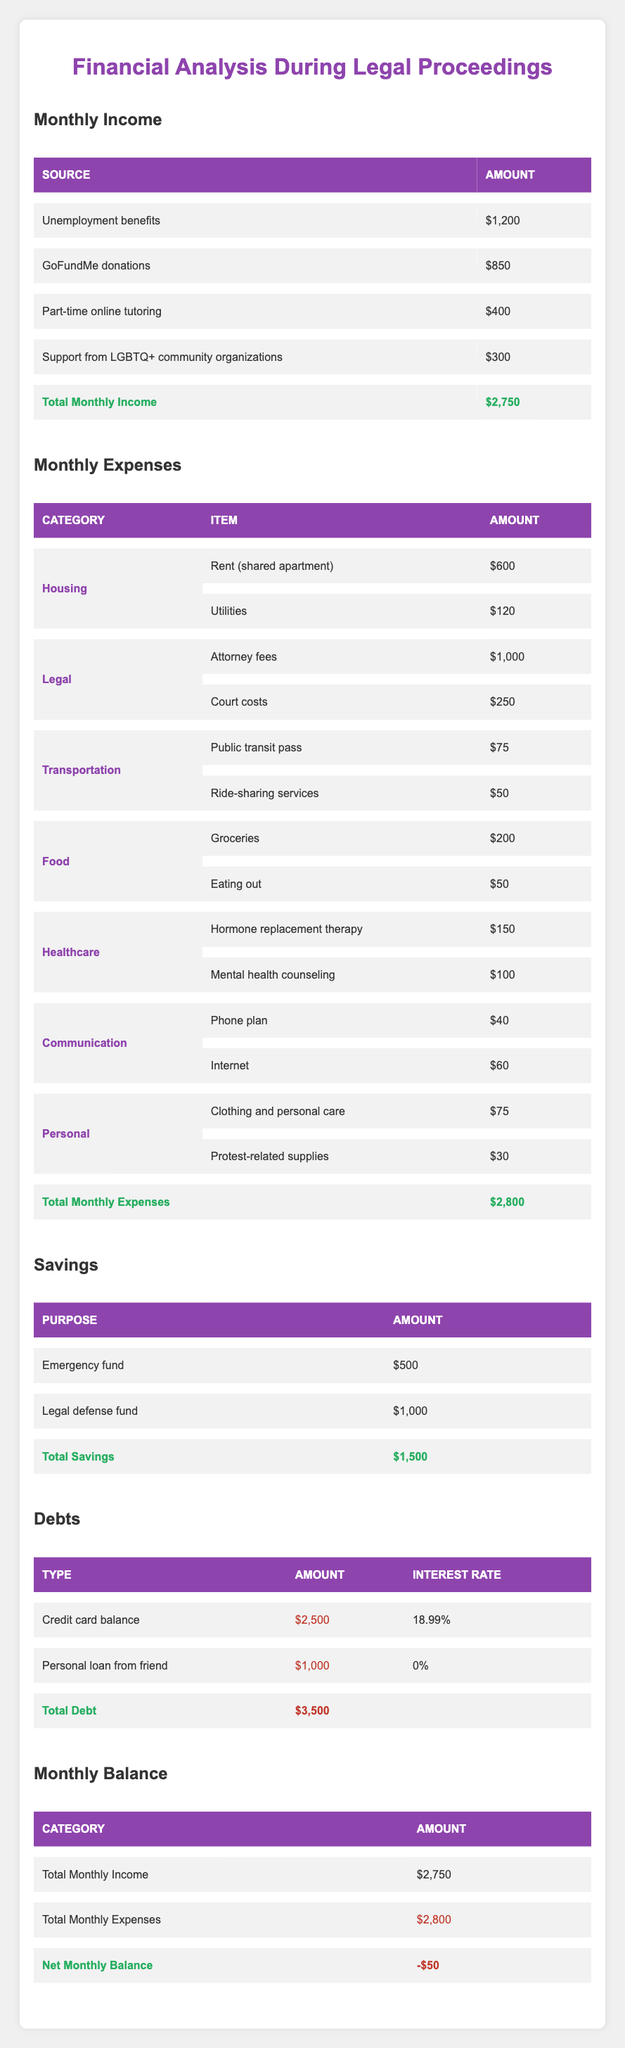What is the total monthly income? By adding all income sources: Unemployment benefits ($1200) + GoFundMe donations ($850) + Part-time online tutoring ($400) + Support from LGBTQ+ community organizations ($300) gives a total of $2750.
Answer: 2750 What are the total monthly expenses? The total monthly expenses can be found by adding all individual expenses: Housing ($720) + Legal ($1250) + Transportation ($125) + Food ($250) + Healthcare ($250) + Communication ($100) + Personal ($105) gives a total of $2800.
Answer: 2800 Is the income greater than the expenses? To determine this, we compare total income ($2750) to total expenses ($2800). Since $2750 is less than $2800, the statement is false.
Answer: No What is the amount of legal fees in the monthly expenses? From the Legal category, the attorney fees are listed as $1000 and court costs as $250. Combined, legal expenses total $1250.
Answer: 1250 What is the net monthly balance? The net monthly balance is calculated by subtracting total expenses ($2800) from total income ($2750), yielding $2750 - $2800 = -$50.
Answer: -50 What percentage of the total monthly income is from GoFundMe donations? To find the percentage contribution of GoFundMe donations ($850) to total income ($2750), divide $850 by $2750 and multiply by 100, resulting in approximately 30.91%.
Answer: 30.91 Are there any expenses in personal care? Reviewing the Personal category, there are expenses for clothing and personal care ($75) and protest-related supplies ($30), confirming there are personal care expenses.
Answer: Yes What is the total amount of savings? To find the total savings, sum the emergency fund ($500) and legal defense fund ($1000), resulting in $500 + $1000 = $1500.
Answer: 1500 If you had to cut one area of expenses, which area has the highest cost? Looking at the monthly expenses, Legal expenses ($1250) are the highest compared to other categories, suggesting this is the area to cut first if needed.
Answer: Legal What is the interest rate on the credit card debt? The credit card balance shows an amount of $2500 and an interest rate of 18.99%, identifying this as the interest rate on the debt.
Answer: 18.99% 